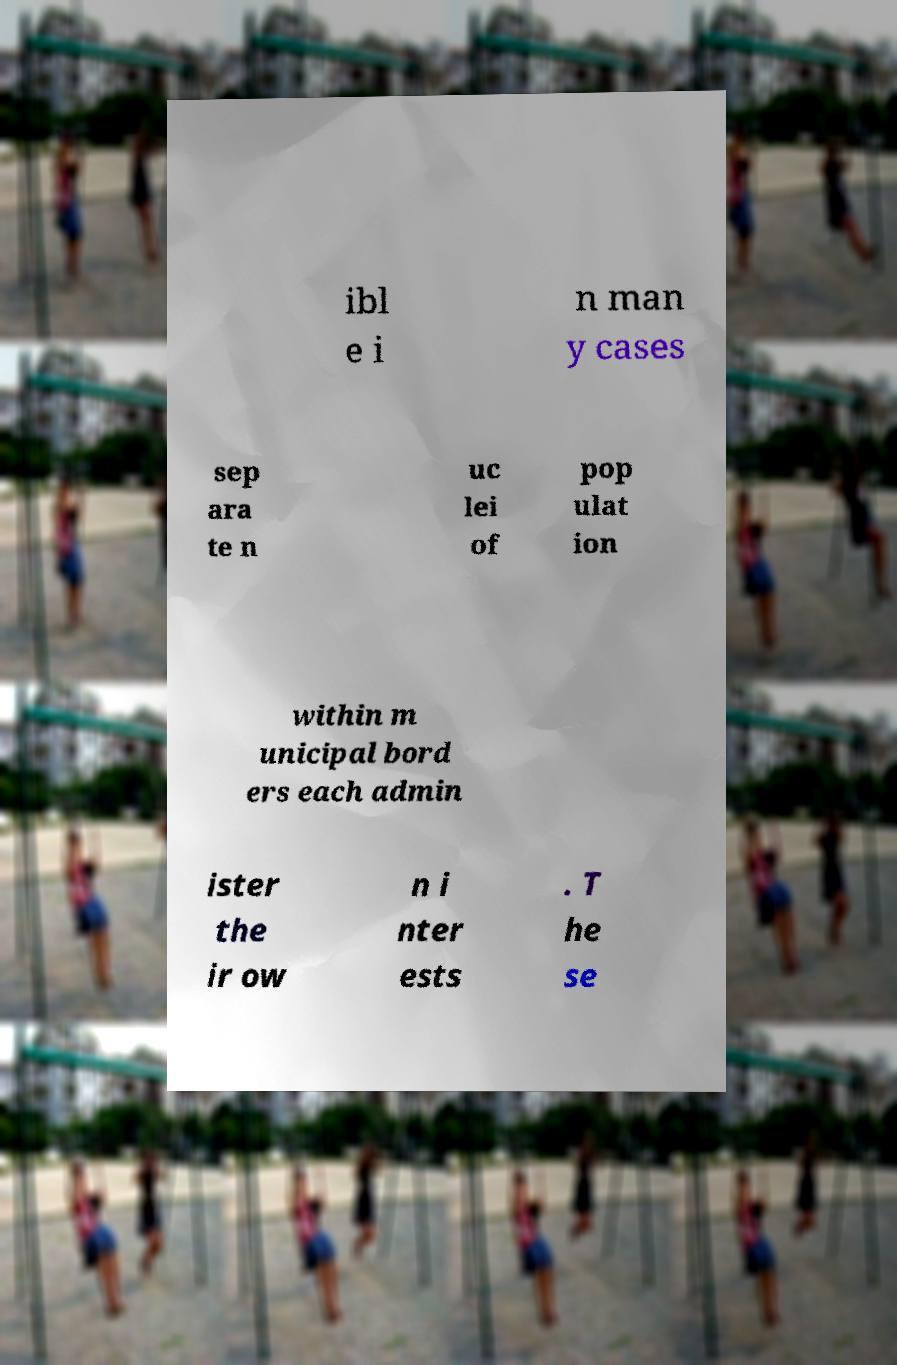I need the written content from this picture converted into text. Can you do that? ibl e i n man y cases sep ara te n uc lei of pop ulat ion within m unicipal bord ers each admin ister the ir ow n i nter ests . T he se 